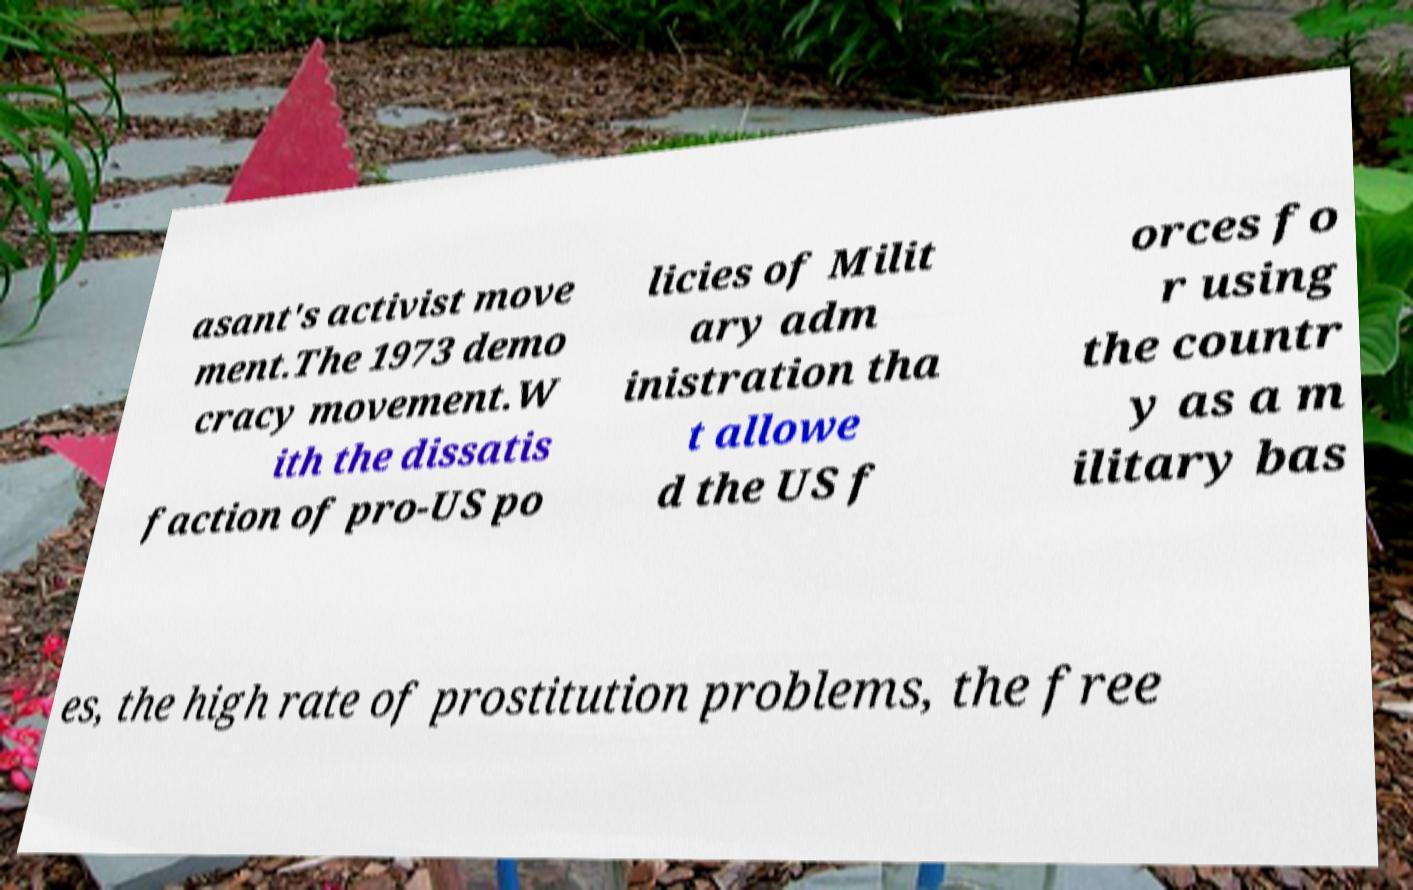Please identify and transcribe the text found in this image. asant's activist move ment.The 1973 demo cracy movement.W ith the dissatis faction of pro-US po licies of Milit ary adm inistration tha t allowe d the US f orces fo r using the countr y as a m ilitary bas es, the high rate of prostitution problems, the free 